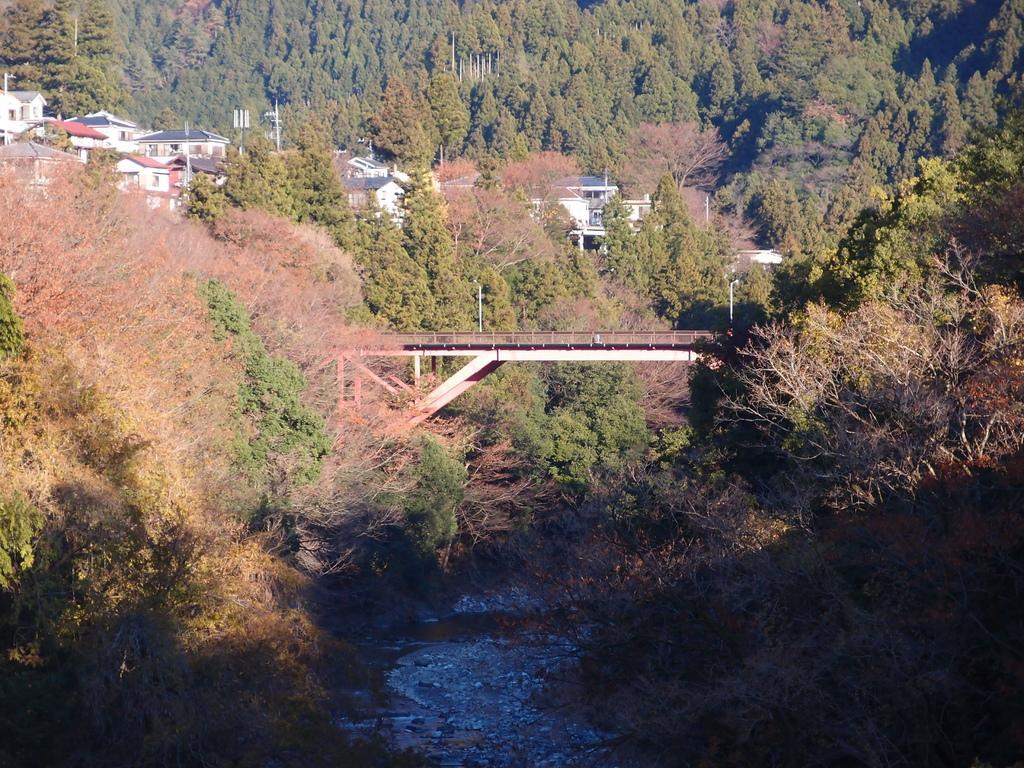How would you summarize this image in a sentence or two? At the bottom of this image I can see the water. In the middle of the image there is a bridge. In the background there are many trees and buildings. 